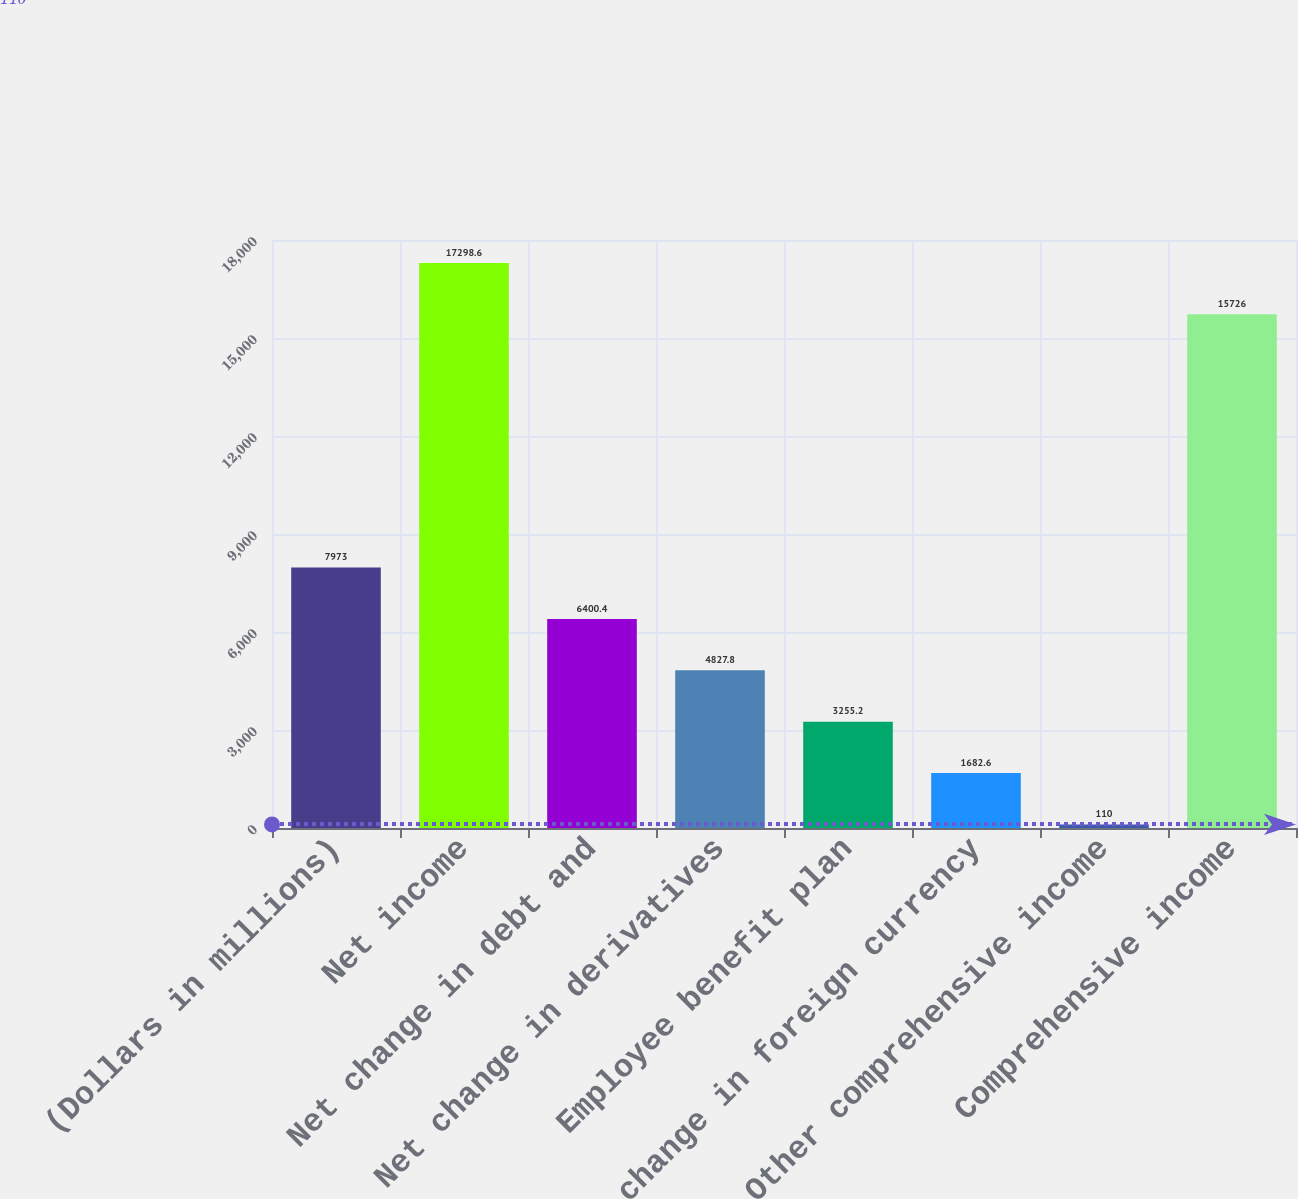Convert chart to OTSL. <chart><loc_0><loc_0><loc_500><loc_500><bar_chart><fcel>(Dollars in millions)<fcel>Net income<fcel>Net change in debt and<fcel>Net change in derivatives<fcel>Employee benefit plan<fcel>Net change in foreign currency<fcel>Other comprehensive income<fcel>Comprehensive income<nl><fcel>7973<fcel>17298.6<fcel>6400.4<fcel>4827.8<fcel>3255.2<fcel>1682.6<fcel>110<fcel>15726<nl></chart> 